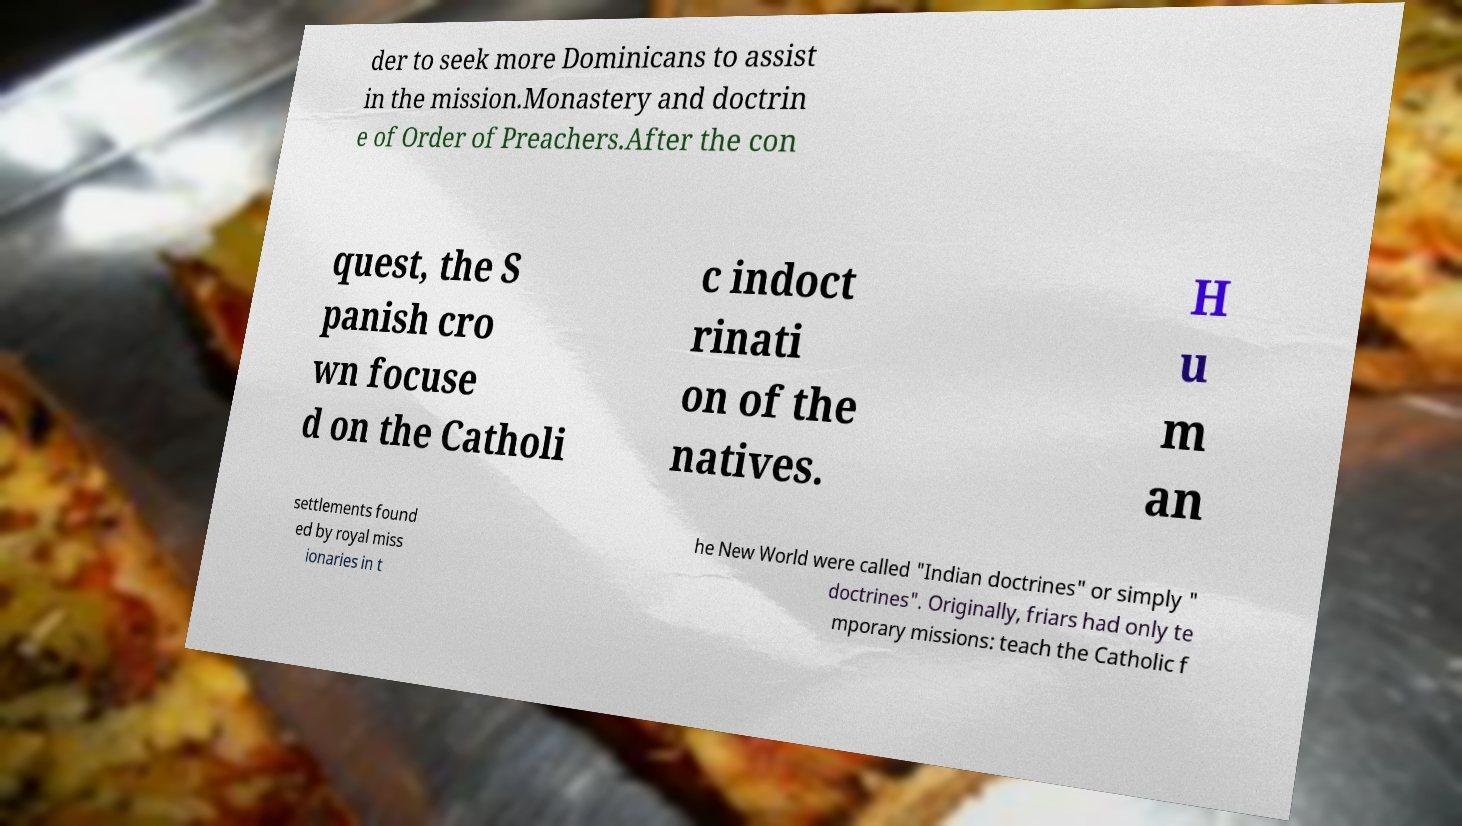There's text embedded in this image that I need extracted. Can you transcribe it verbatim? der to seek more Dominicans to assist in the mission.Monastery and doctrin e of Order of Preachers.After the con quest, the S panish cro wn focuse d on the Catholi c indoct rinati on of the natives. H u m an settlements found ed by royal miss ionaries in t he New World were called "Indian doctrines" or simply " doctrines". Originally, friars had only te mporary missions: teach the Catholic f 